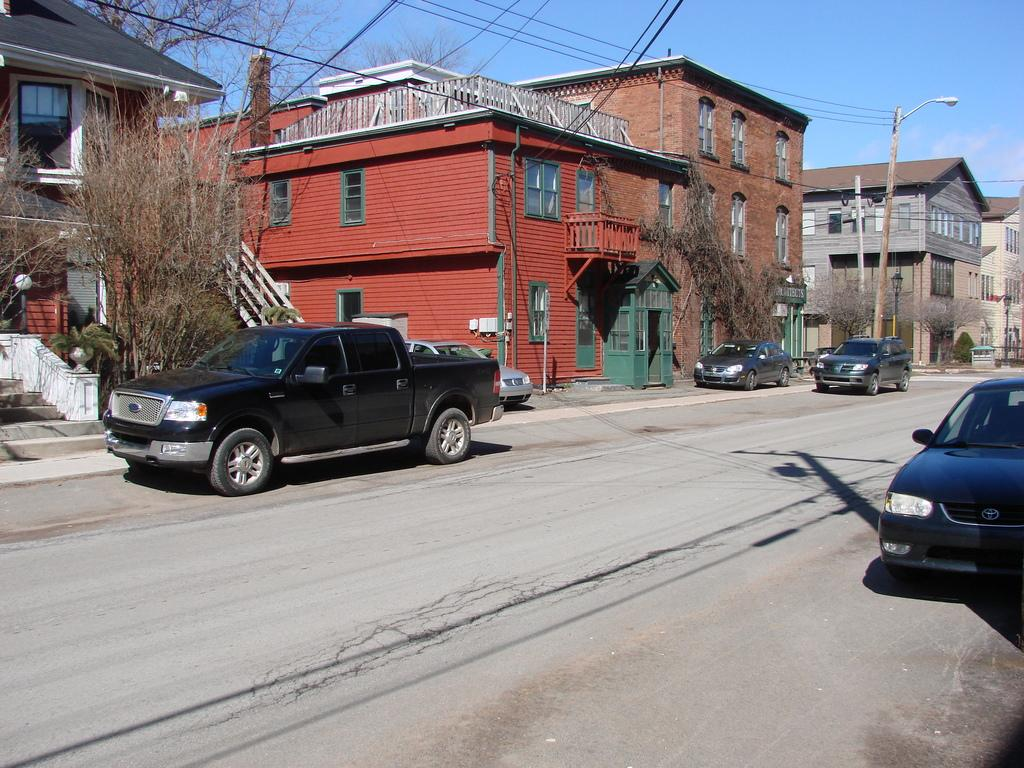What can be seen on the road in the image? There are vehicles on the road in the image. What structures are present along the road? There are light poles in the image. What else can be seen in the image besides the road and vehicles? Electric wires, houses, trees, and clouds are visible in the image. How much peace can be found in the image? The concept of "peace" is not directly observable in the image, as it is an abstract concept. However, the image does show a scene with vehicles, light poles, electric wires, houses, trees, and clouds, which may evoke a sense of calm or tranquility for some viewers. 